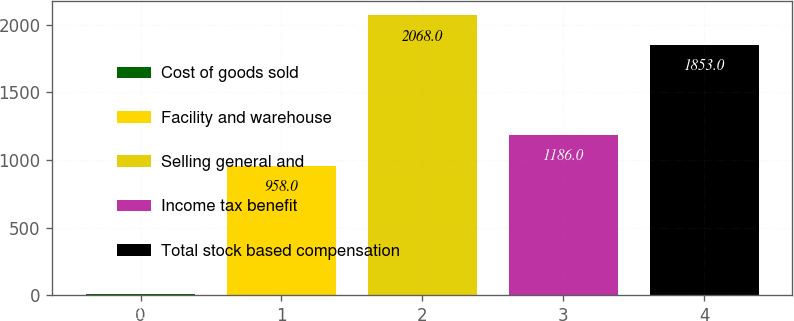<chart> <loc_0><loc_0><loc_500><loc_500><bar_chart><fcel>Cost of goods sold<fcel>Facility and warehouse<fcel>Selling general and<fcel>Income tax benefit<fcel>Total stock based compensation<nl><fcel>13<fcel>958<fcel>2068<fcel>1186<fcel>1853<nl></chart> 